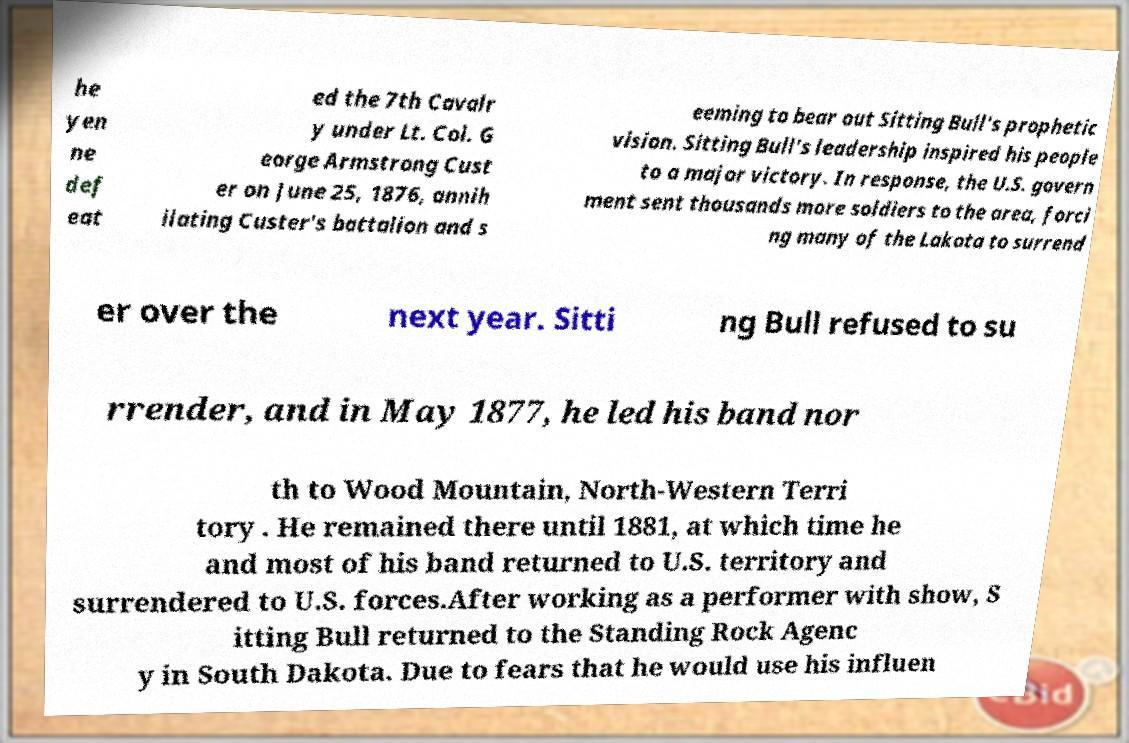Can you accurately transcribe the text from the provided image for me? he yen ne def eat ed the 7th Cavalr y under Lt. Col. G eorge Armstrong Cust er on June 25, 1876, annih ilating Custer's battalion and s eeming to bear out Sitting Bull's prophetic vision. Sitting Bull's leadership inspired his people to a major victory. In response, the U.S. govern ment sent thousands more soldiers to the area, forci ng many of the Lakota to surrend er over the next year. Sitti ng Bull refused to su rrender, and in May 1877, he led his band nor th to Wood Mountain, North-Western Terri tory . He remained there until 1881, at which time he and most of his band returned to U.S. territory and surrendered to U.S. forces.After working as a performer with show, S itting Bull returned to the Standing Rock Agenc y in South Dakota. Due to fears that he would use his influen 